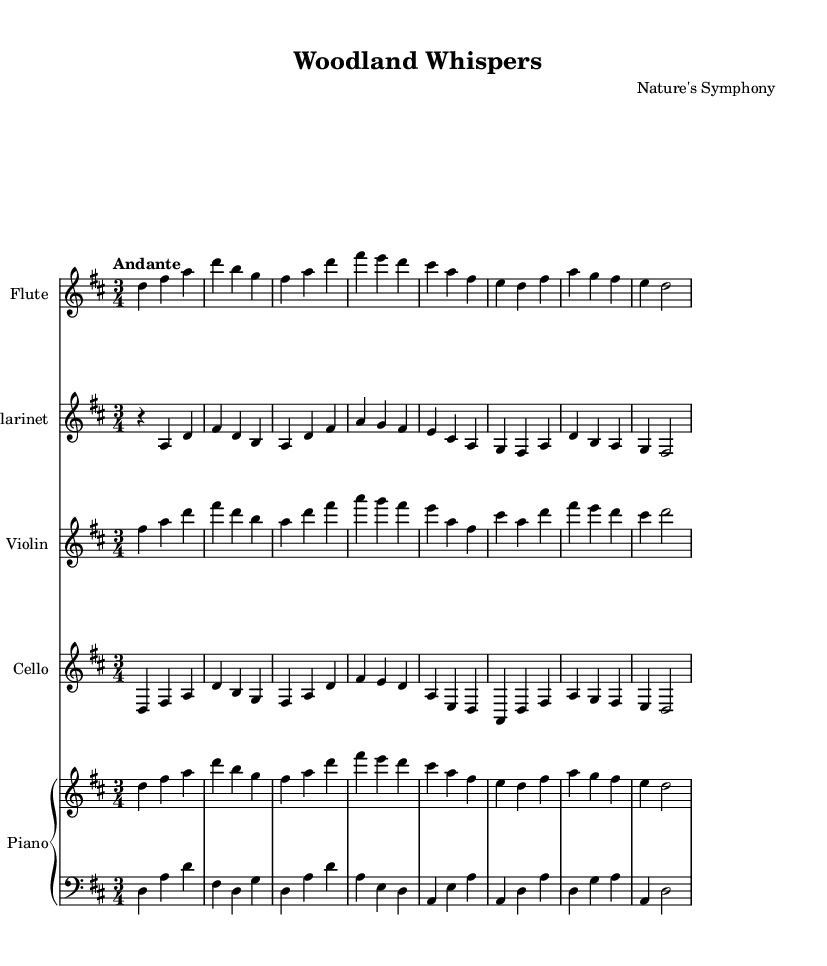What is the key signature of this music? The key signature is indicated at the beginning of the score. In this case, it shows two sharps, which correspond to F# and C#. This confirms that the piece is in D major.
Answer: D major What is the time signature of this music? The time signature appears as a fraction at the beginning of the score. Here, it shows 3 over 4, indicating that there are three beats in each measure and the quarter note gets one beat.
Answer: 3/4 What is the tempo marking for this piece? The tempo is indicated in the score under the global settings. Here it is marked "Andante," which typically means a moderate walking pace.
Answer: Andante How many measures are in the flute part? By counting the musical phrases and the subdivisions in the flute part, it can be determined that it contains eight measures in total.
Answer: Eight Which instruments are featured in this composition? The score lists the instruments in the header section and the parts below. The instruments featured are Flute, Clarinet, Violin, Cello, and Piano.
Answer: Flute, Clarinet, Violin, Cello, Piano What is the dynamic marking in the left hand piano part? In the left hand piano part, the dynamic marking indicates it should be played softly, as seen with the marking "p" standing for "piano."
Answer: Piano Are there any rests included in the clarinet part? Reviewing the clarinet part, the rest appears in the first measure, where there is a whole measure rest before the clarinet plays any notes.
Answer: Yes 